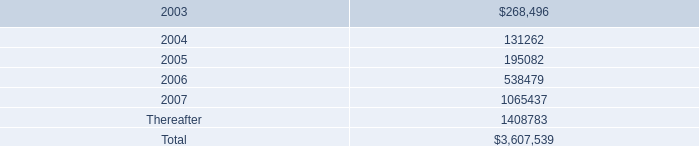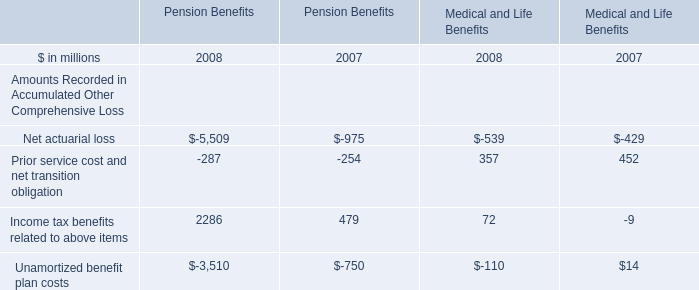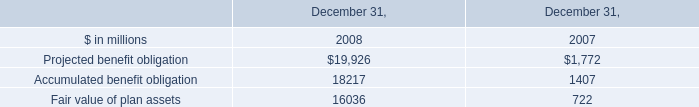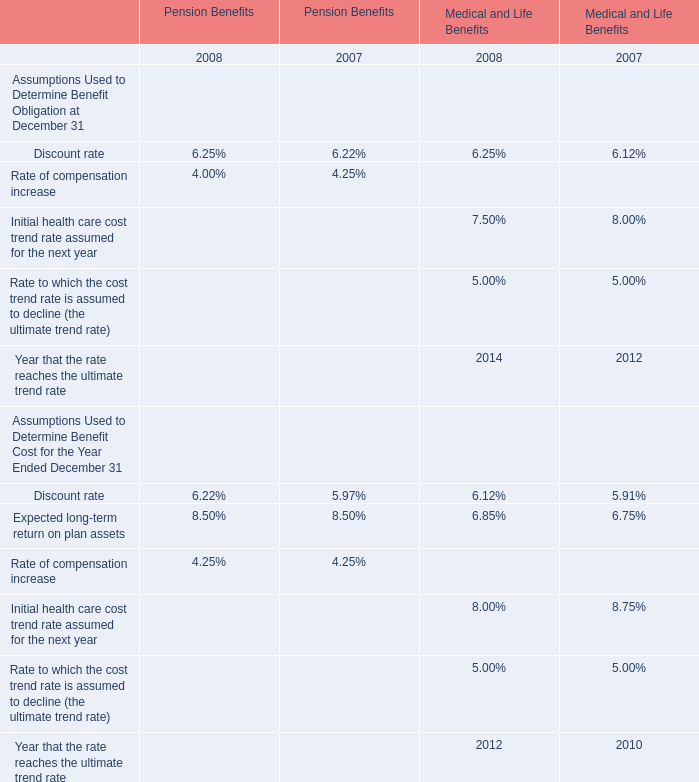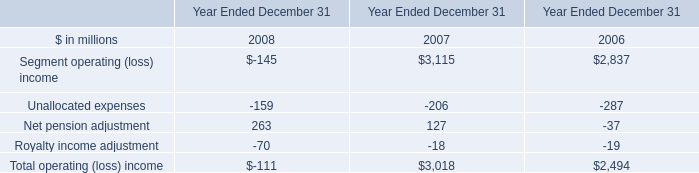What's the increasing rate of Income tax benefits related to above items in 2007 Pension Benefits ? 
Computations: ((2286 - 479) / 479)
Answer: 3.77244. 